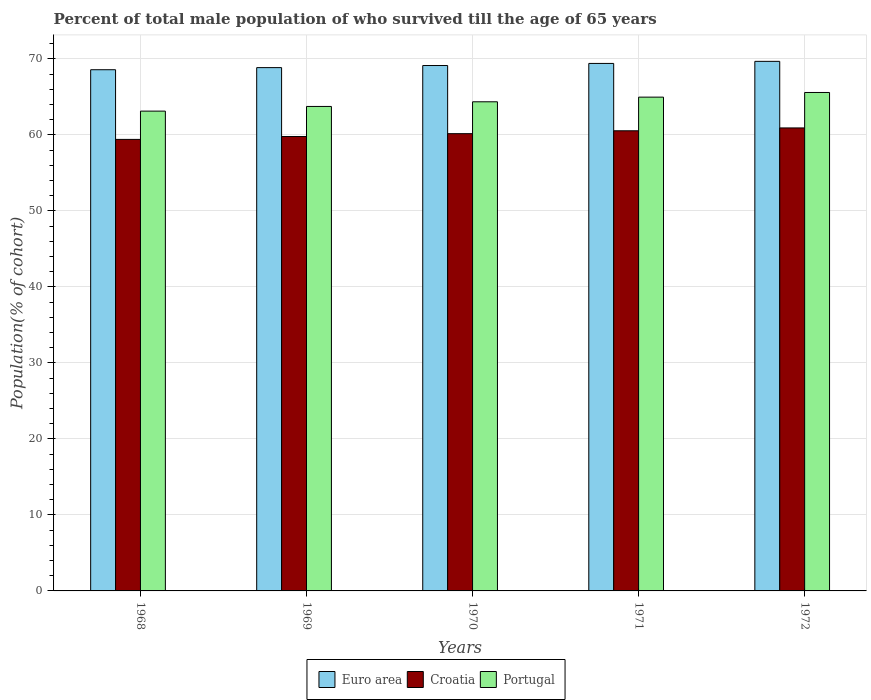How many groups of bars are there?
Provide a succinct answer. 5. Are the number of bars per tick equal to the number of legend labels?
Provide a short and direct response. Yes. How many bars are there on the 5th tick from the left?
Keep it short and to the point. 3. How many bars are there on the 4th tick from the right?
Your answer should be very brief. 3. In how many cases, is the number of bars for a given year not equal to the number of legend labels?
Your answer should be compact. 0. What is the percentage of total male population who survived till the age of 65 years in Croatia in 1972?
Your response must be concise. 60.92. Across all years, what is the maximum percentage of total male population who survived till the age of 65 years in Croatia?
Keep it short and to the point. 60.92. Across all years, what is the minimum percentage of total male population who survived till the age of 65 years in Portugal?
Give a very brief answer. 63.13. In which year was the percentage of total male population who survived till the age of 65 years in Croatia maximum?
Offer a terse response. 1972. In which year was the percentage of total male population who survived till the age of 65 years in Croatia minimum?
Keep it short and to the point. 1968. What is the total percentage of total male population who survived till the age of 65 years in Euro area in the graph?
Your answer should be compact. 345.62. What is the difference between the percentage of total male population who survived till the age of 65 years in Portugal in 1969 and that in 1970?
Provide a short and direct response. -0.61. What is the difference between the percentage of total male population who survived till the age of 65 years in Portugal in 1970 and the percentage of total male population who survived till the age of 65 years in Euro area in 1972?
Give a very brief answer. -5.32. What is the average percentage of total male population who survived till the age of 65 years in Croatia per year?
Your answer should be very brief. 60.16. In the year 1969, what is the difference between the percentage of total male population who survived till the age of 65 years in Portugal and percentage of total male population who survived till the age of 65 years in Euro area?
Provide a succinct answer. -5.11. In how many years, is the percentage of total male population who survived till the age of 65 years in Croatia greater than 48 %?
Keep it short and to the point. 5. What is the ratio of the percentage of total male population who survived till the age of 65 years in Euro area in 1968 to that in 1972?
Keep it short and to the point. 0.98. Is the difference between the percentage of total male population who survived till the age of 65 years in Portugal in 1969 and 1972 greater than the difference between the percentage of total male population who survived till the age of 65 years in Euro area in 1969 and 1972?
Your answer should be compact. No. What is the difference between the highest and the second highest percentage of total male population who survived till the age of 65 years in Portugal?
Offer a terse response. 0.61. What is the difference between the highest and the lowest percentage of total male population who survived till the age of 65 years in Croatia?
Offer a very short reply. 1.51. Is the sum of the percentage of total male population who survived till the age of 65 years in Portugal in 1969 and 1970 greater than the maximum percentage of total male population who survived till the age of 65 years in Croatia across all years?
Your answer should be compact. Yes. What does the 3rd bar from the right in 1969 represents?
Your answer should be very brief. Euro area. Are the values on the major ticks of Y-axis written in scientific E-notation?
Give a very brief answer. No. Does the graph contain any zero values?
Give a very brief answer. No. Does the graph contain grids?
Provide a succinct answer. Yes. How many legend labels are there?
Your answer should be compact. 3. How are the legend labels stacked?
Offer a terse response. Horizontal. What is the title of the graph?
Ensure brevity in your answer.  Percent of total male population of who survived till the age of 65 years. What is the label or title of the Y-axis?
Offer a very short reply. Population(% of cohort). What is the Population(% of cohort) of Euro area in 1968?
Give a very brief answer. 68.57. What is the Population(% of cohort) of Croatia in 1968?
Provide a succinct answer. 59.41. What is the Population(% of cohort) in Portugal in 1968?
Ensure brevity in your answer.  63.13. What is the Population(% of cohort) in Euro area in 1969?
Your response must be concise. 68.85. What is the Population(% of cohort) in Croatia in 1969?
Make the answer very short. 59.78. What is the Population(% of cohort) in Portugal in 1969?
Provide a short and direct response. 63.74. What is the Population(% of cohort) of Euro area in 1970?
Your answer should be compact. 69.13. What is the Population(% of cohort) of Croatia in 1970?
Ensure brevity in your answer.  60.16. What is the Population(% of cohort) in Portugal in 1970?
Offer a very short reply. 64.35. What is the Population(% of cohort) in Euro area in 1971?
Ensure brevity in your answer.  69.4. What is the Population(% of cohort) of Croatia in 1971?
Provide a succinct answer. 60.54. What is the Population(% of cohort) of Portugal in 1971?
Ensure brevity in your answer.  64.97. What is the Population(% of cohort) in Euro area in 1972?
Ensure brevity in your answer.  69.67. What is the Population(% of cohort) in Croatia in 1972?
Your answer should be very brief. 60.92. What is the Population(% of cohort) in Portugal in 1972?
Keep it short and to the point. 65.58. Across all years, what is the maximum Population(% of cohort) of Euro area?
Keep it short and to the point. 69.67. Across all years, what is the maximum Population(% of cohort) of Croatia?
Offer a very short reply. 60.92. Across all years, what is the maximum Population(% of cohort) in Portugal?
Ensure brevity in your answer.  65.58. Across all years, what is the minimum Population(% of cohort) of Euro area?
Your response must be concise. 68.57. Across all years, what is the minimum Population(% of cohort) in Croatia?
Provide a succinct answer. 59.41. Across all years, what is the minimum Population(% of cohort) in Portugal?
Your answer should be very brief. 63.13. What is the total Population(% of cohort) of Euro area in the graph?
Your response must be concise. 345.62. What is the total Population(% of cohort) in Croatia in the graph?
Your response must be concise. 300.8. What is the total Population(% of cohort) of Portugal in the graph?
Your answer should be very brief. 321.77. What is the difference between the Population(% of cohort) in Euro area in 1968 and that in 1969?
Your response must be concise. -0.28. What is the difference between the Population(% of cohort) of Croatia in 1968 and that in 1969?
Your answer should be very brief. -0.38. What is the difference between the Population(% of cohort) of Portugal in 1968 and that in 1969?
Give a very brief answer. -0.61. What is the difference between the Population(% of cohort) of Euro area in 1968 and that in 1970?
Provide a succinct answer. -0.55. What is the difference between the Population(% of cohort) in Croatia in 1968 and that in 1970?
Your response must be concise. -0.75. What is the difference between the Population(% of cohort) in Portugal in 1968 and that in 1970?
Provide a succinct answer. -1.23. What is the difference between the Population(% of cohort) of Euro area in 1968 and that in 1971?
Offer a terse response. -0.83. What is the difference between the Population(% of cohort) in Croatia in 1968 and that in 1971?
Provide a short and direct response. -1.13. What is the difference between the Population(% of cohort) of Portugal in 1968 and that in 1971?
Offer a terse response. -1.84. What is the difference between the Population(% of cohort) of Euro area in 1968 and that in 1972?
Offer a very short reply. -1.1. What is the difference between the Population(% of cohort) in Croatia in 1968 and that in 1972?
Offer a terse response. -1.51. What is the difference between the Population(% of cohort) of Portugal in 1968 and that in 1972?
Provide a short and direct response. -2.45. What is the difference between the Population(% of cohort) of Euro area in 1969 and that in 1970?
Ensure brevity in your answer.  -0.28. What is the difference between the Population(% of cohort) of Croatia in 1969 and that in 1970?
Give a very brief answer. -0.38. What is the difference between the Population(% of cohort) of Portugal in 1969 and that in 1970?
Keep it short and to the point. -0.61. What is the difference between the Population(% of cohort) in Euro area in 1969 and that in 1971?
Ensure brevity in your answer.  -0.55. What is the difference between the Population(% of cohort) in Croatia in 1969 and that in 1971?
Provide a short and direct response. -0.75. What is the difference between the Population(% of cohort) of Portugal in 1969 and that in 1971?
Provide a short and direct response. -1.23. What is the difference between the Population(% of cohort) in Euro area in 1969 and that in 1972?
Ensure brevity in your answer.  -0.82. What is the difference between the Population(% of cohort) in Croatia in 1969 and that in 1972?
Offer a very short reply. -1.13. What is the difference between the Population(% of cohort) of Portugal in 1969 and that in 1972?
Offer a terse response. -1.84. What is the difference between the Population(% of cohort) of Euro area in 1970 and that in 1971?
Offer a very short reply. -0.28. What is the difference between the Population(% of cohort) in Croatia in 1970 and that in 1971?
Your response must be concise. -0.38. What is the difference between the Population(% of cohort) in Portugal in 1970 and that in 1971?
Offer a very short reply. -0.61. What is the difference between the Population(% of cohort) of Euro area in 1970 and that in 1972?
Offer a terse response. -0.55. What is the difference between the Population(% of cohort) in Croatia in 1970 and that in 1972?
Offer a very short reply. -0.75. What is the difference between the Population(% of cohort) of Portugal in 1970 and that in 1972?
Provide a succinct answer. -1.23. What is the difference between the Population(% of cohort) of Euro area in 1971 and that in 1972?
Give a very brief answer. -0.27. What is the difference between the Population(% of cohort) of Croatia in 1971 and that in 1972?
Your answer should be compact. -0.38. What is the difference between the Population(% of cohort) in Portugal in 1971 and that in 1972?
Your answer should be very brief. -0.61. What is the difference between the Population(% of cohort) in Euro area in 1968 and the Population(% of cohort) in Croatia in 1969?
Your answer should be compact. 8.79. What is the difference between the Population(% of cohort) in Euro area in 1968 and the Population(% of cohort) in Portugal in 1969?
Your answer should be compact. 4.83. What is the difference between the Population(% of cohort) in Croatia in 1968 and the Population(% of cohort) in Portugal in 1969?
Your answer should be compact. -4.33. What is the difference between the Population(% of cohort) of Euro area in 1968 and the Population(% of cohort) of Croatia in 1970?
Your response must be concise. 8.41. What is the difference between the Population(% of cohort) in Euro area in 1968 and the Population(% of cohort) in Portugal in 1970?
Keep it short and to the point. 4.22. What is the difference between the Population(% of cohort) of Croatia in 1968 and the Population(% of cohort) of Portugal in 1970?
Offer a very short reply. -4.95. What is the difference between the Population(% of cohort) of Euro area in 1968 and the Population(% of cohort) of Croatia in 1971?
Offer a very short reply. 8.04. What is the difference between the Population(% of cohort) of Euro area in 1968 and the Population(% of cohort) of Portugal in 1971?
Offer a very short reply. 3.61. What is the difference between the Population(% of cohort) of Croatia in 1968 and the Population(% of cohort) of Portugal in 1971?
Offer a terse response. -5.56. What is the difference between the Population(% of cohort) in Euro area in 1968 and the Population(% of cohort) in Croatia in 1972?
Offer a terse response. 7.66. What is the difference between the Population(% of cohort) in Euro area in 1968 and the Population(% of cohort) in Portugal in 1972?
Provide a short and direct response. 2.99. What is the difference between the Population(% of cohort) of Croatia in 1968 and the Population(% of cohort) of Portugal in 1972?
Offer a very short reply. -6.17. What is the difference between the Population(% of cohort) in Euro area in 1969 and the Population(% of cohort) in Croatia in 1970?
Make the answer very short. 8.69. What is the difference between the Population(% of cohort) of Euro area in 1969 and the Population(% of cohort) of Portugal in 1970?
Give a very brief answer. 4.5. What is the difference between the Population(% of cohort) of Croatia in 1969 and the Population(% of cohort) of Portugal in 1970?
Keep it short and to the point. -4.57. What is the difference between the Population(% of cohort) of Euro area in 1969 and the Population(% of cohort) of Croatia in 1971?
Ensure brevity in your answer.  8.31. What is the difference between the Population(% of cohort) of Euro area in 1969 and the Population(% of cohort) of Portugal in 1971?
Offer a very short reply. 3.88. What is the difference between the Population(% of cohort) in Croatia in 1969 and the Population(% of cohort) in Portugal in 1971?
Keep it short and to the point. -5.18. What is the difference between the Population(% of cohort) in Euro area in 1969 and the Population(% of cohort) in Croatia in 1972?
Keep it short and to the point. 7.93. What is the difference between the Population(% of cohort) of Euro area in 1969 and the Population(% of cohort) of Portugal in 1972?
Your response must be concise. 3.27. What is the difference between the Population(% of cohort) in Croatia in 1969 and the Population(% of cohort) in Portugal in 1972?
Give a very brief answer. -5.8. What is the difference between the Population(% of cohort) of Euro area in 1970 and the Population(% of cohort) of Croatia in 1971?
Keep it short and to the point. 8.59. What is the difference between the Population(% of cohort) of Euro area in 1970 and the Population(% of cohort) of Portugal in 1971?
Your response must be concise. 4.16. What is the difference between the Population(% of cohort) in Croatia in 1970 and the Population(% of cohort) in Portugal in 1971?
Give a very brief answer. -4.81. What is the difference between the Population(% of cohort) of Euro area in 1970 and the Population(% of cohort) of Croatia in 1972?
Offer a very short reply. 8.21. What is the difference between the Population(% of cohort) in Euro area in 1970 and the Population(% of cohort) in Portugal in 1972?
Make the answer very short. 3.55. What is the difference between the Population(% of cohort) in Croatia in 1970 and the Population(% of cohort) in Portugal in 1972?
Offer a very short reply. -5.42. What is the difference between the Population(% of cohort) in Euro area in 1971 and the Population(% of cohort) in Croatia in 1972?
Provide a succinct answer. 8.49. What is the difference between the Population(% of cohort) of Euro area in 1971 and the Population(% of cohort) of Portugal in 1972?
Your response must be concise. 3.82. What is the difference between the Population(% of cohort) of Croatia in 1971 and the Population(% of cohort) of Portugal in 1972?
Keep it short and to the point. -5.04. What is the average Population(% of cohort) in Euro area per year?
Offer a terse response. 69.12. What is the average Population(% of cohort) of Croatia per year?
Your response must be concise. 60.16. What is the average Population(% of cohort) in Portugal per year?
Your answer should be very brief. 64.35. In the year 1968, what is the difference between the Population(% of cohort) in Euro area and Population(% of cohort) in Croatia?
Make the answer very short. 9.17. In the year 1968, what is the difference between the Population(% of cohort) in Euro area and Population(% of cohort) in Portugal?
Make the answer very short. 5.45. In the year 1968, what is the difference between the Population(% of cohort) of Croatia and Population(% of cohort) of Portugal?
Provide a succinct answer. -3.72. In the year 1969, what is the difference between the Population(% of cohort) of Euro area and Population(% of cohort) of Croatia?
Provide a short and direct response. 9.07. In the year 1969, what is the difference between the Population(% of cohort) in Euro area and Population(% of cohort) in Portugal?
Your answer should be compact. 5.11. In the year 1969, what is the difference between the Population(% of cohort) in Croatia and Population(% of cohort) in Portugal?
Your response must be concise. -3.96. In the year 1970, what is the difference between the Population(% of cohort) in Euro area and Population(% of cohort) in Croatia?
Provide a short and direct response. 8.97. In the year 1970, what is the difference between the Population(% of cohort) in Euro area and Population(% of cohort) in Portugal?
Provide a short and direct response. 4.77. In the year 1970, what is the difference between the Population(% of cohort) of Croatia and Population(% of cohort) of Portugal?
Offer a terse response. -4.19. In the year 1971, what is the difference between the Population(% of cohort) of Euro area and Population(% of cohort) of Croatia?
Keep it short and to the point. 8.86. In the year 1971, what is the difference between the Population(% of cohort) in Euro area and Population(% of cohort) in Portugal?
Provide a short and direct response. 4.43. In the year 1971, what is the difference between the Population(% of cohort) in Croatia and Population(% of cohort) in Portugal?
Make the answer very short. -4.43. In the year 1972, what is the difference between the Population(% of cohort) of Euro area and Population(% of cohort) of Croatia?
Offer a very short reply. 8.76. In the year 1972, what is the difference between the Population(% of cohort) in Euro area and Population(% of cohort) in Portugal?
Your answer should be very brief. 4.09. In the year 1972, what is the difference between the Population(% of cohort) of Croatia and Population(% of cohort) of Portugal?
Provide a succinct answer. -4.66. What is the ratio of the Population(% of cohort) of Euro area in 1968 to that in 1969?
Keep it short and to the point. 1. What is the ratio of the Population(% of cohort) in Portugal in 1968 to that in 1969?
Your answer should be very brief. 0.99. What is the ratio of the Population(% of cohort) in Croatia in 1968 to that in 1970?
Your answer should be compact. 0.99. What is the ratio of the Population(% of cohort) in Portugal in 1968 to that in 1970?
Your answer should be very brief. 0.98. What is the ratio of the Population(% of cohort) of Croatia in 1968 to that in 1971?
Make the answer very short. 0.98. What is the ratio of the Population(% of cohort) in Portugal in 1968 to that in 1971?
Your answer should be compact. 0.97. What is the ratio of the Population(% of cohort) in Euro area in 1968 to that in 1972?
Keep it short and to the point. 0.98. What is the ratio of the Population(% of cohort) of Croatia in 1968 to that in 1972?
Provide a short and direct response. 0.98. What is the ratio of the Population(% of cohort) in Portugal in 1968 to that in 1972?
Give a very brief answer. 0.96. What is the ratio of the Population(% of cohort) in Croatia in 1969 to that in 1970?
Make the answer very short. 0.99. What is the ratio of the Population(% of cohort) of Portugal in 1969 to that in 1970?
Your response must be concise. 0.99. What is the ratio of the Population(% of cohort) of Croatia in 1969 to that in 1971?
Your answer should be very brief. 0.99. What is the ratio of the Population(% of cohort) in Portugal in 1969 to that in 1971?
Your answer should be compact. 0.98. What is the ratio of the Population(% of cohort) of Croatia in 1969 to that in 1972?
Give a very brief answer. 0.98. What is the ratio of the Population(% of cohort) of Croatia in 1970 to that in 1971?
Make the answer very short. 0.99. What is the ratio of the Population(% of cohort) of Portugal in 1970 to that in 1971?
Ensure brevity in your answer.  0.99. What is the ratio of the Population(% of cohort) of Euro area in 1970 to that in 1972?
Provide a succinct answer. 0.99. What is the ratio of the Population(% of cohort) of Croatia in 1970 to that in 1972?
Make the answer very short. 0.99. What is the ratio of the Population(% of cohort) of Portugal in 1970 to that in 1972?
Provide a short and direct response. 0.98. What is the ratio of the Population(% of cohort) of Euro area in 1971 to that in 1972?
Keep it short and to the point. 1. What is the ratio of the Population(% of cohort) of Portugal in 1971 to that in 1972?
Make the answer very short. 0.99. What is the difference between the highest and the second highest Population(% of cohort) in Euro area?
Offer a terse response. 0.27. What is the difference between the highest and the second highest Population(% of cohort) in Croatia?
Make the answer very short. 0.38. What is the difference between the highest and the second highest Population(% of cohort) of Portugal?
Your response must be concise. 0.61. What is the difference between the highest and the lowest Population(% of cohort) of Euro area?
Offer a very short reply. 1.1. What is the difference between the highest and the lowest Population(% of cohort) of Croatia?
Ensure brevity in your answer.  1.51. What is the difference between the highest and the lowest Population(% of cohort) in Portugal?
Give a very brief answer. 2.45. 